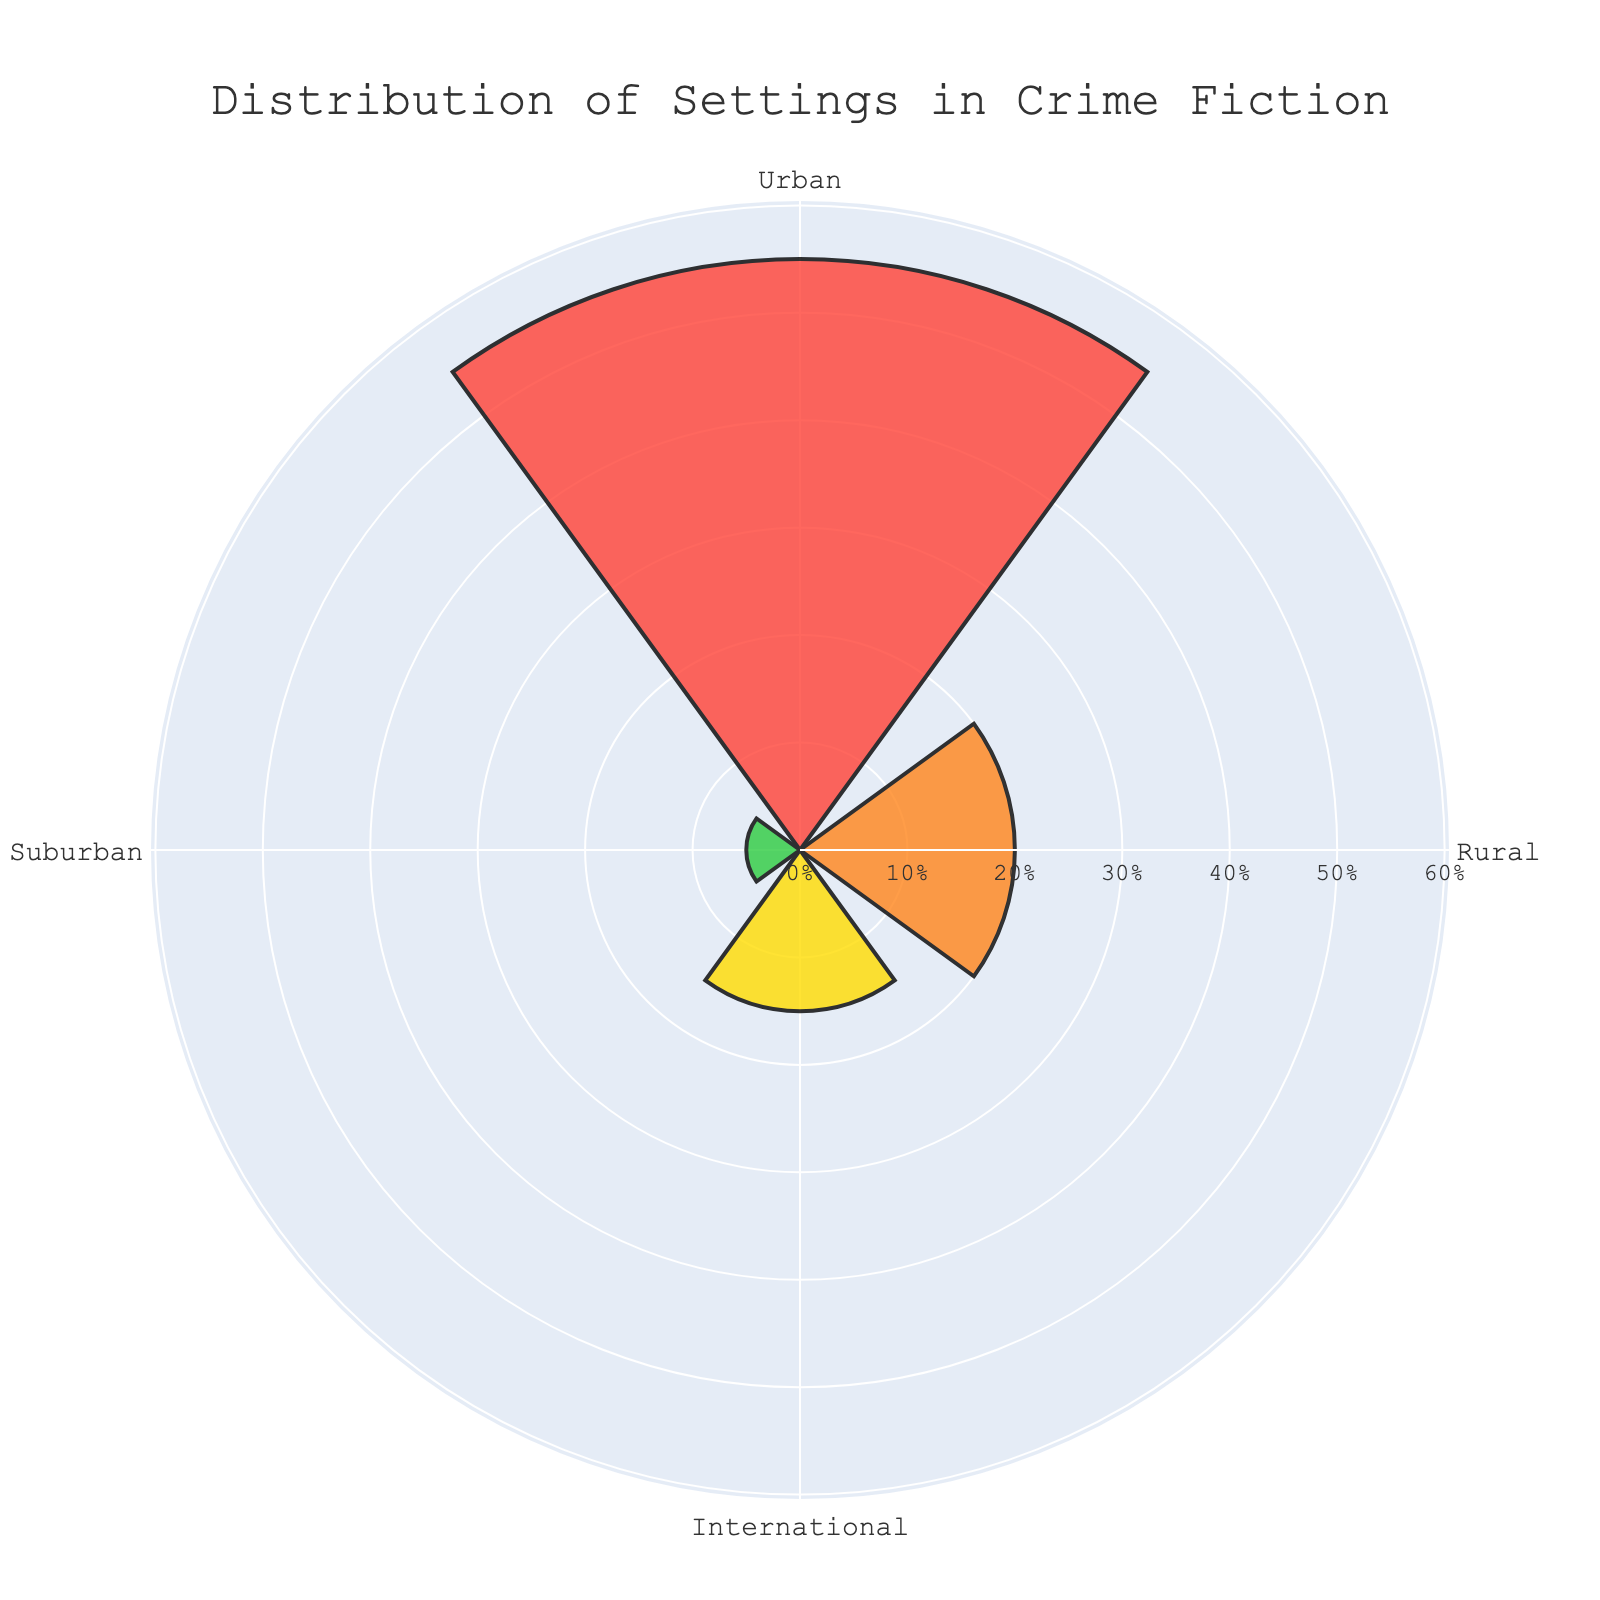What percentage of crime fiction settings are urban? The chart shows that the urban setting occupies 55% of the total area in the polar area chart.
Answer: 55% Which setting has the smallest proportion in crime fiction? The chart indicates that the suburban setting has the smallest proportional area at 5%.
Answer: Suburban What is the combined percentage of rural and international settings? To find the combined percentage, add the values for rural (20%) and international (15%) settings: 20% + 15% = 35%.
Answer: 35% How much larger is the urban setting proportion compared to the suburban setting? Subtract the suburban percentage (5%) from the urban percentage (55%): 55% - 5% = 50%.
Answer: 50% Rank the settings from the most to the least common. The chart shows the following percentages: Urban (55%), Rural (20%), International (15%), Suburban (5%). Thus, the ranking is Urban, Rural, International, Suburban.
Answer: Urban, Rural, International, Suburban Does the chart show any radial axis ticks? Yes, the chart displays radial axis ticks with percentage markers.
Answer: Yes Is the international setting more or less common than the suburban setting? The chart indicates that the international setting is more common at 15% compared to the suburban setting at 5%.
Answer: More Which settings occupy more than 50% together? To determine this, sum the percentages of the most common settings until they exceed 50%. Urban alone is 55%, so it already surpasses 50%.
Answer: Urban What percentage of crime fiction settings are neither urban nor rural? Subtract the combined percentage of urban (55%) and rural (20%) settings from 100%: 100% - (55% + 20%) = 25%.
Answer: 25% Describe the color used for the rural setting. The color used for the rural setting in the chart is an orange-like hue.
Answer: Orange 